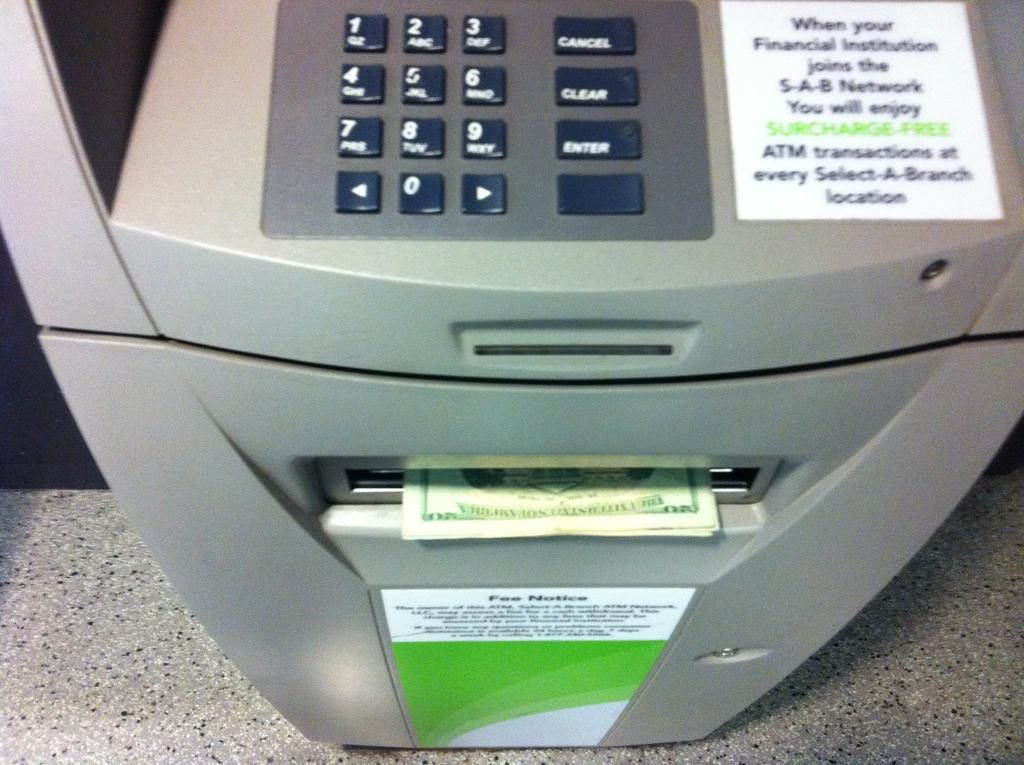<image>
Present a compact description of the photo's key features. People that join the institutions will get surcharge free transactions. 